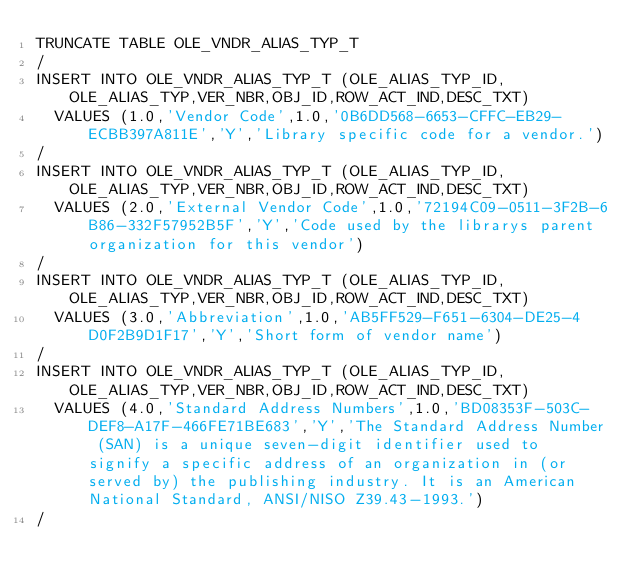Convert code to text. <code><loc_0><loc_0><loc_500><loc_500><_SQL_>TRUNCATE TABLE OLE_VNDR_ALIAS_TYP_T
/
INSERT INTO OLE_VNDR_ALIAS_TYP_T (OLE_ALIAS_TYP_ID,OLE_ALIAS_TYP,VER_NBR,OBJ_ID,ROW_ACT_IND,DESC_TXT)
  VALUES (1.0,'Vendor Code',1.0,'0B6DD568-6653-CFFC-EB29-ECBB397A811E','Y','Library specific code for a vendor.')
/
INSERT INTO OLE_VNDR_ALIAS_TYP_T (OLE_ALIAS_TYP_ID,OLE_ALIAS_TYP,VER_NBR,OBJ_ID,ROW_ACT_IND,DESC_TXT)
  VALUES (2.0,'External Vendor Code',1.0,'72194C09-0511-3F2B-6B86-332F57952B5F','Y','Code used by the librarys parent organization for this vendor')
/
INSERT INTO OLE_VNDR_ALIAS_TYP_T (OLE_ALIAS_TYP_ID,OLE_ALIAS_TYP,VER_NBR,OBJ_ID,ROW_ACT_IND,DESC_TXT)
  VALUES (3.0,'Abbreviation',1.0,'AB5FF529-F651-6304-DE25-4D0F2B9D1F17','Y','Short form of vendor name')
/
INSERT INTO OLE_VNDR_ALIAS_TYP_T (OLE_ALIAS_TYP_ID,OLE_ALIAS_TYP,VER_NBR,OBJ_ID,ROW_ACT_IND,DESC_TXT)
  VALUES (4.0,'Standard Address Numbers',1.0,'BD08353F-503C-DEF8-A17F-466FE71BE683','Y','The Standard Address Number (SAN) is a unique seven-digit identifier used to signify a specific address of an organization in (or served by) the publishing industry. It is an American National Standard, ANSI/NISO Z39.43-1993.')
/
</code> 